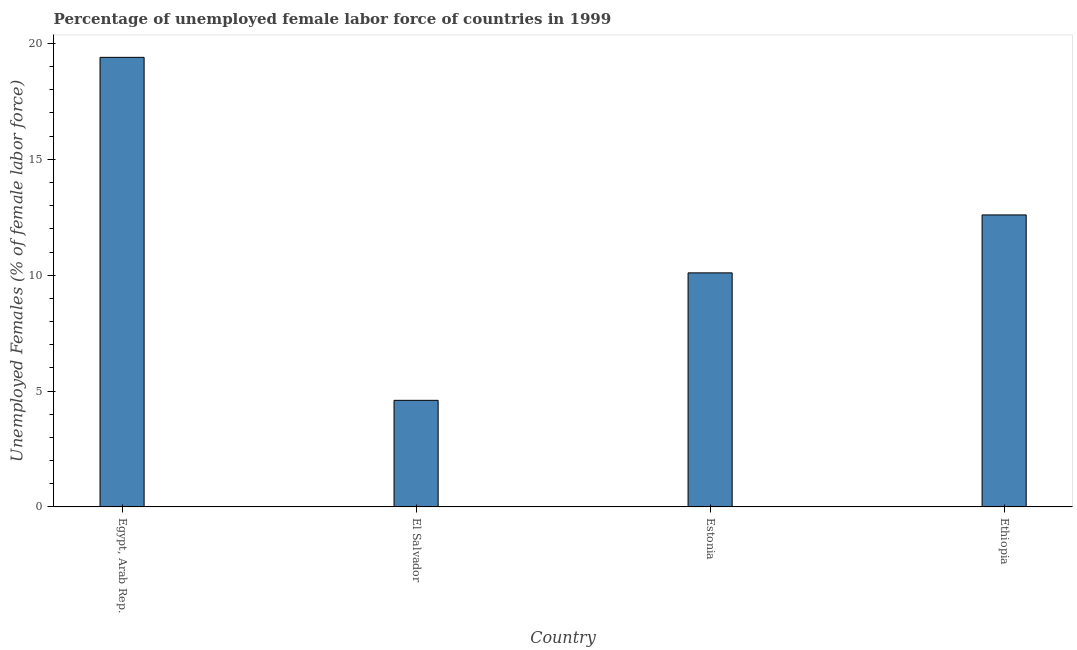Does the graph contain any zero values?
Offer a terse response. No. Does the graph contain grids?
Give a very brief answer. No. What is the title of the graph?
Make the answer very short. Percentage of unemployed female labor force of countries in 1999. What is the label or title of the X-axis?
Provide a short and direct response. Country. What is the label or title of the Y-axis?
Provide a short and direct response. Unemployed Females (% of female labor force). What is the total unemployed female labour force in Estonia?
Your response must be concise. 10.1. Across all countries, what is the maximum total unemployed female labour force?
Offer a terse response. 19.4. Across all countries, what is the minimum total unemployed female labour force?
Make the answer very short. 4.6. In which country was the total unemployed female labour force maximum?
Provide a succinct answer. Egypt, Arab Rep. In which country was the total unemployed female labour force minimum?
Make the answer very short. El Salvador. What is the sum of the total unemployed female labour force?
Offer a terse response. 46.7. What is the average total unemployed female labour force per country?
Offer a terse response. 11.68. What is the median total unemployed female labour force?
Offer a very short reply. 11.35. In how many countries, is the total unemployed female labour force greater than 2 %?
Make the answer very short. 4. What is the ratio of the total unemployed female labour force in El Salvador to that in Ethiopia?
Give a very brief answer. 0.36. Are all the bars in the graph horizontal?
Ensure brevity in your answer.  No. What is the difference between two consecutive major ticks on the Y-axis?
Ensure brevity in your answer.  5. What is the Unemployed Females (% of female labor force) in Egypt, Arab Rep.?
Keep it short and to the point. 19.4. What is the Unemployed Females (% of female labor force) in El Salvador?
Offer a terse response. 4.6. What is the Unemployed Females (% of female labor force) in Estonia?
Provide a succinct answer. 10.1. What is the Unemployed Females (% of female labor force) in Ethiopia?
Offer a very short reply. 12.6. What is the difference between the Unemployed Females (% of female labor force) in Egypt, Arab Rep. and El Salvador?
Your response must be concise. 14.8. What is the difference between the Unemployed Females (% of female labor force) in Egypt, Arab Rep. and Ethiopia?
Keep it short and to the point. 6.8. What is the ratio of the Unemployed Females (% of female labor force) in Egypt, Arab Rep. to that in El Salvador?
Your answer should be very brief. 4.22. What is the ratio of the Unemployed Females (% of female labor force) in Egypt, Arab Rep. to that in Estonia?
Keep it short and to the point. 1.92. What is the ratio of the Unemployed Females (% of female labor force) in Egypt, Arab Rep. to that in Ethiopia?
Provide a short and direct response. 1.54. What is the ratio of the Unemployed Females (% of female labor force) in El Salvador to that in Estonia?
Provide a succinct answer. 0.46. What is the ratio of the Unemployed Females (% of female labor force) in El Salvador to that in Ethiopia?
Your response must be concise. 0.36. What is the ratio of the Unemployed Females (% of female labor force) in Estonia to that in Ethiopia?
Ensure brevity in your answer.  0.8. 